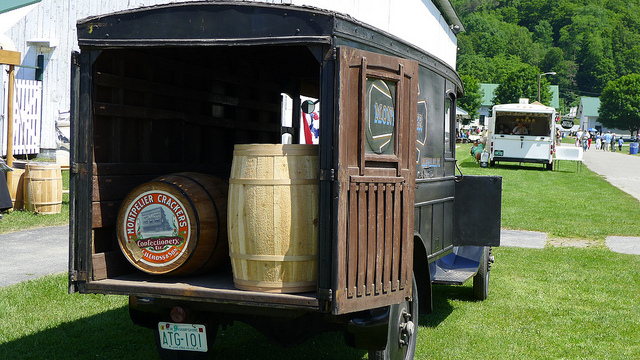Please identify all text content in this image. MONTPELIER CRACKERS ATG 101 